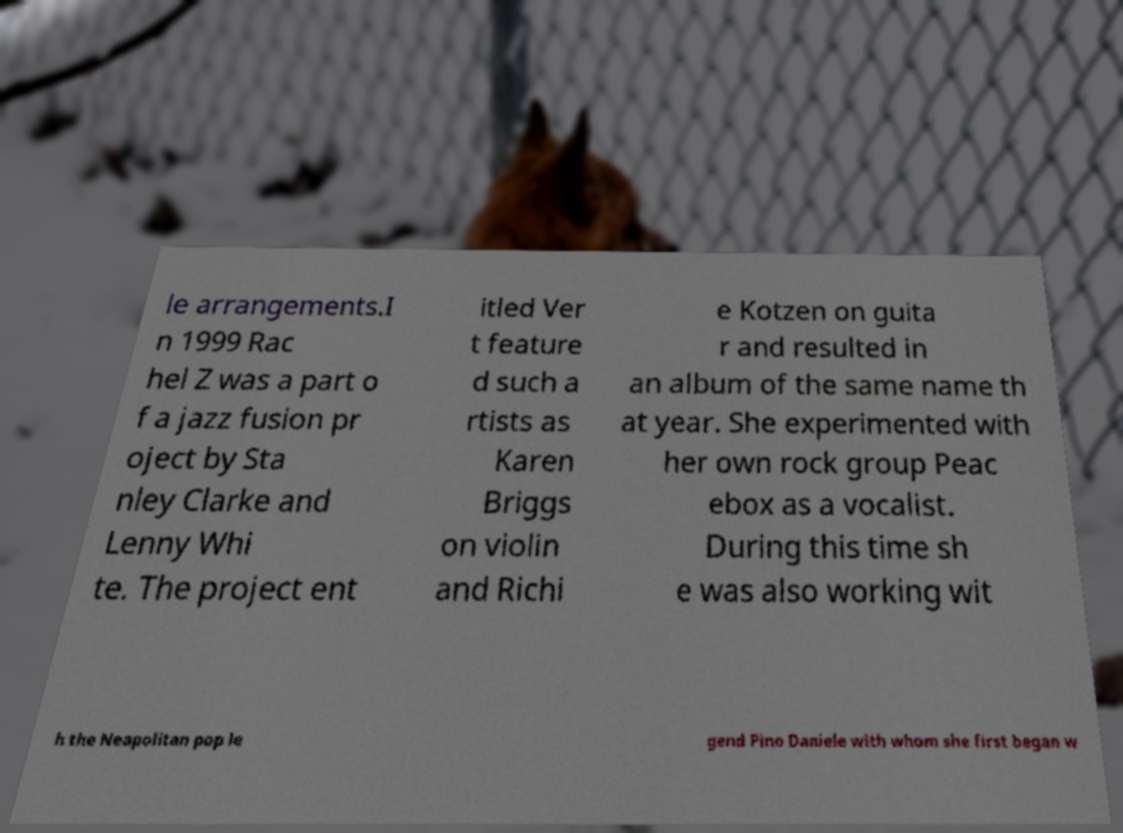What messages or text are displayed in this image? I need them in a readable, typed format. le arrangements.I n 1999 Rac hel Z was a part o f a jazz fusion pr oject by Sta nley Clarke and Lenny Whi te. The project ent itled Ver t feature d such a rtists as Karen Briggs on violin and Richi e Kotzen on guita r and resulted in an album of the same name th at year. She experimented with her own rock group Peac ebox as a vocalist. During this time sh e was also working wit h the Neapolitan pop le gend Pino Daniele with whom she first began w 